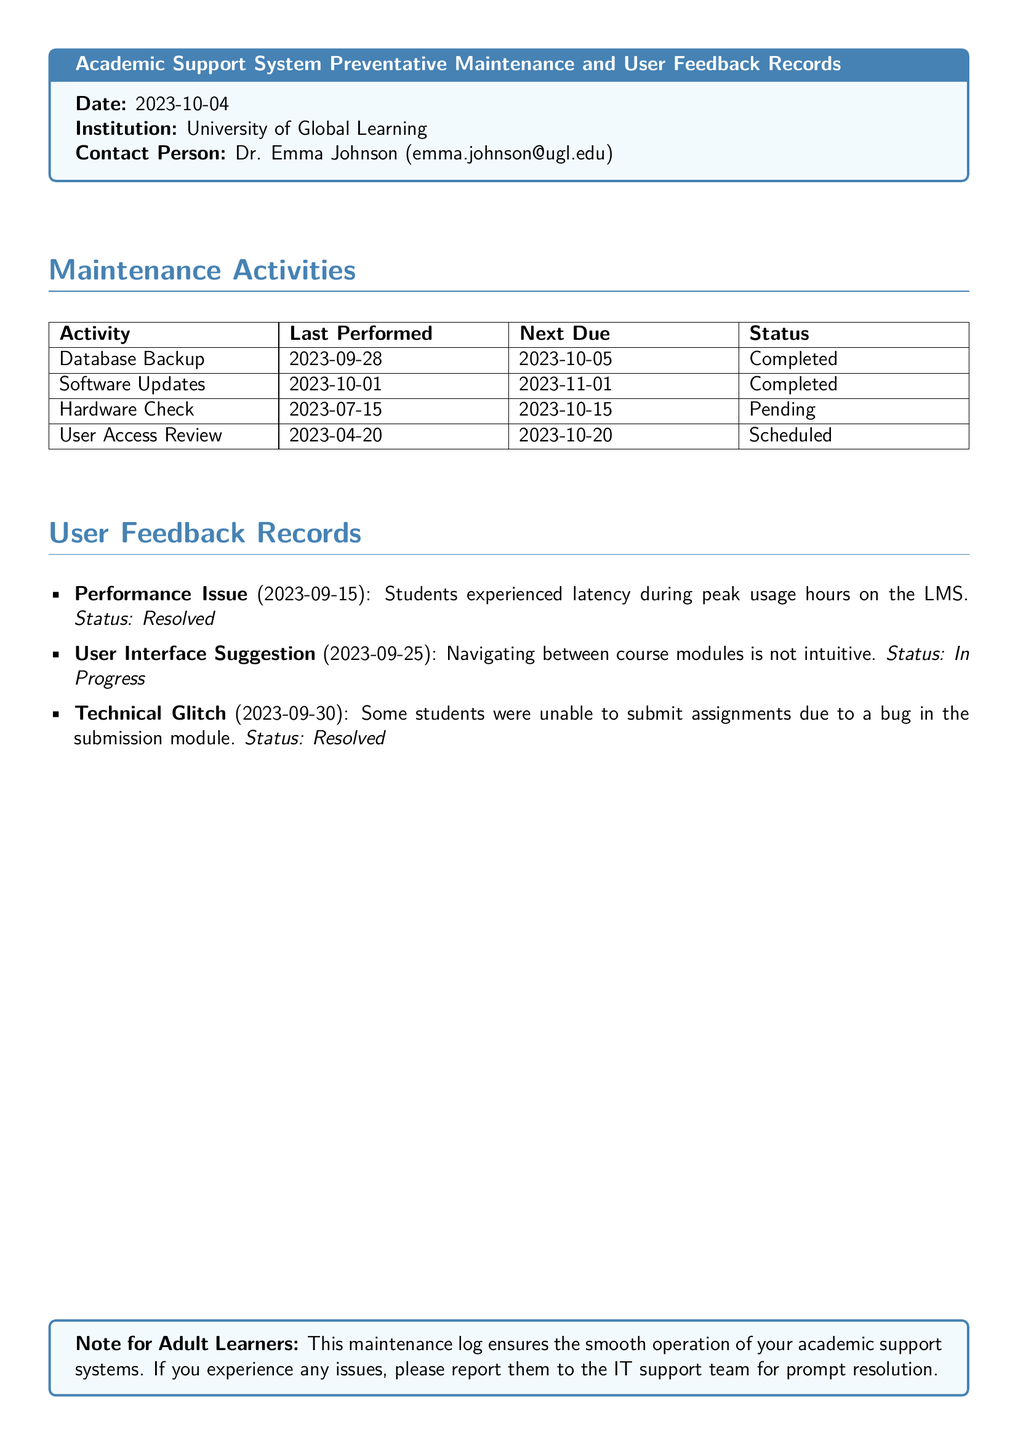What is the date of the maintenance log? The date of the maintenance log is indicated clearly at the top of the log entry.
Answer: 2023-10-04 Who is the contact person for the maintenance log? The contact person is specified in the log and includes their name and email for communication.
Answer: Dr. Emma Johnson What is the next due date for the Database Backup? The next due date for the Database Backup is stated in the maintenance activities table.
Answer: 2023-10-05 What is the status of the Hardware Check? The status of the Hardware Check is part of the maintenance activities listed in the document.
Answer: Pending How many user feedback records are resolved? The number of resolved user feedback records can be deduced from the feedback list.
Answer: 2 What type of issue was reported on 2023-09-25? The type of the issue reported is mentioned along with the date in the user feedback records.
Answer: User Interface Suggestion What maintenance activity is scheduled for 2023-10-20? The scheduled activity is detailed in the maintenance activities table.
Answer: User Access Review What was the issue reported on 2023-09-30? The specific issue is provided in the user feedback records along with its date and status.
Answer: Technical Glitch What was the status of the performance issue reported on 2023-09-15? The status is mentioned right after the description of the issue in the user feedback records.
Answer: Resolved 